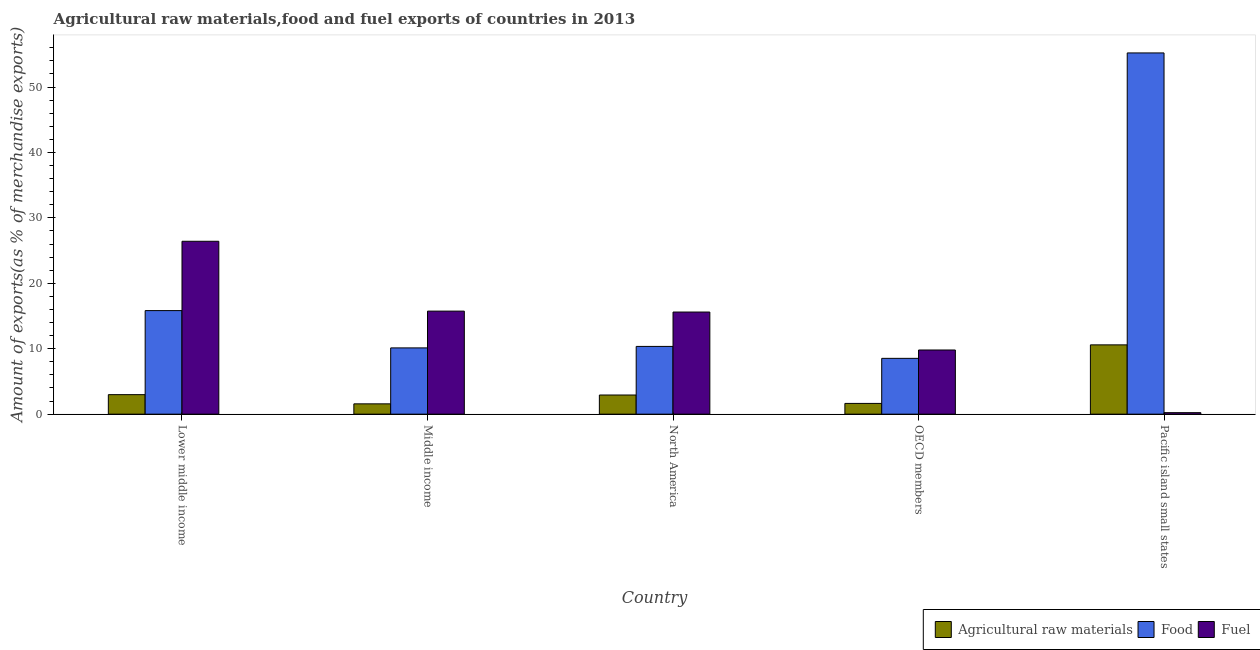How many different coloured bars are there?
Offer a terse response. 3. How many groups of bars are there?
Offer a terse response. 5. How many bars are there on the 1st tick from the left?
Offer a terse response. 3. What is the label of the 5th group of bars from the left?
Your answer should be very brief. Pacific island small states. In how many cases, is the number of bars for a given country not equal to the number of legend labels?
Provide a succinct answer. 0. What is the percentage of fuel exports in Middle income?
Provide a short and direct response. 15.75. Across all countries, what is the maximum percentage of raw materials exports?
Your answer should be very brief. 10.59. Across all countries, what is the minimum percentage of food exports?
Your answer should be compact. 8.53. In which country was the percentage of raw materials exports maximum?
Your answer should be very brief. Pacific island small states. In which country was the percentage of fuel exports minimum?
Your answer should be compact. Pacific island small states. What is the total percentage of food exports in the graph?
Provide a short and direct response. 100.06. What is the difference between the percentage of fuel exports in Lower middle income and that in North America?
Your response must be concise. 10.82. What is the difference between the percentage of fuel exports in Pacific island small states and the percentage of raw materials exports in OECD members?
Your answer should be compact. -1.41. What is the average percentage of food exports per country?
Keep it short and to the point. 20.01. What is the difference between the percentage of food exports and percentage of raw materials exports in Lower middle income?
Provide a short and direct response. 12.85. In how many countries, is the percentage of raw materials exports greater than 26 %?
Your response must be concise. 0. What is the ratio of the percentage of raw materials exports in Lower middle income to that in OECD members?
Give a very brief answer. 1.82. Is the percentage of fuel exports in Lower middle income less than that in Pacific island small states?
Keep it short and to the point. No. Is the difference between the percentage of fuel exports in North America and OECD members greater than the difference between the percentage of food exports in North America and OECD members?
Offer a terse response. Yes. What is the difference between the highest and the second highest percentage of raw materials exports?
Give a very brief answer. 7.61. What is the difference between the highest and the lowest percentage of fuel exports?
Provide a succinct answer. 26.19. In how many countries, is the percentage of fuel exports greater than the average percentage of fuel exports taken over all countries?
Your response must be concise. 3. Is the sum of the percentage of fuel exports in Middle income and Pacific island small states greater than the maximum percentage of food exports across all countries?
Give a very brief answer. No. What does the 2nd bar from the left in Middle income represents?
Your answer should be compact. Food. What does the 3rd bar from the right in Pacific island small states represents?
Your response must be concise. Agricultural raw materials. Is it the case that in every country, the sum of the percentage of raw materials exports and percentage of food exports is greater than the percentage of fuel exports?
Keep it short and to the point. No. Are all the bars in the graph horizontal?
Your answer should be compact. No. What is the difference between two consecutive major ticks on the Y-axis?
Ensure brevity in your answer.  10. Does the graph contain any zero values?
Your answer should be very brief. No. What is the title of the graph?
Keep it short and to the point. Agricultural raw materials,food and fuel exports of countries in 2013. What is the label or title of the Y-axis?
Ensure brevity in your answer.  Amount of exports(as % of merchandise exports). What is the Amount of exports(as % of merchandise exports) of Agricultural raw materials in Lower middle income?
Provide a succinct answer. 2.98. What is the Amount of exports(as % of merchandise exports) of Food in Lower middle income?
Make the answer very short. 15.83. What is the Amount of exports(as % of merchandise exports) of Fuel in Lower middle income?
Offer a very short reply. 26.42. What is the Amount of exports(as % of merchandise exports) of Agricultural raw materials in Middle income?
Ensure brevity in your answer.  1.58. What is the Amount of exports(as % of merchandise exports) in Food in Middle income?
Provide a short and direct response. 10.13. What is the Amount of exports(as % of merchandise exports) in Fuel in Middle income?
Keep it short and to the point. 15.75. What is the Amount of exports(as % of merchandise exports) of Agricultural raw materials in North America?
Offer a very short reply. 2.93. What is the Amount of exports(as % of merchandise exports) of Food in North America?
Offer a terse response. 10.35. What is the Amount of exports(as % of merchandise exports) in Fuel in North America?
Your response must be concise. 15.61. What is the Amount of exports(as % of merchandise exports) of Agricultural raw materials in OECD members?
Keep it short and to the point. 1.64. What is the Amount of exports(as % of merchandise exports) in Food in OECD members?
Provide a short and direct response. 8.53. What is the Amount of exports(as % of merchandise exports) in Fuel in OECD members?
Provide a short and direct response. 9.81. What is the Amount of exports(as % of merchandise exports) in Agricultural raw materials in Pacific island small states?
Your answer should be compact. 10.59. What is the Amount of exports(as % of merchandise exports) in Food in Pacific island small states?
Keep it short and to the point. 55.21. What is the Amount of exports(as % of merchandise exports) of Fuel in Pacific island small states?
Keep it short and to the point. 0.23. Across all countries, what is the maximum Amount of exports(as % of merchandise exports) in Agricultural raw materials?
Provide a short and direct response. 10.59. Across all countries, what is the maximum Amount of exports(as % of merchandise exports) in Food?
Your answer should be compact. 55.21. Across all countries, what is the maximum Amount of exports(as % of merchandise exports) of Fuel?
Your answer should be very brief. 26.42. Across all countries, what is the minimum Amount of exports(as % of merchandise exports) in Agricultural raw materials?
Provide a short and direct response. 1.58. Across all countries, what is the minimum Amount of exports(as % of merchandise exports) in Food?
Keep it short and to the point. 8.53. Across all countries, what is the minimum Amount of exports(as % of merchandise exports) in Fuel?
Provide a succinct answer. 0.23. What is the total Amount of exports(as % of merchandise exports) in Agricultural raw materials in the graph?
Your answer should be compact. 19.72. What is the total Amount of exports(as % of merchandise exports) in Food in the graph?
Make the answer very short. 100.06. What is the total Amount of exports(as % of merchandise exports) in Fuel in the graph?
Make the answer very short. 67.82. What is the difference between the Amount of exports(as % of merchandise exports) of Agricultural raw materials in Lower middle income and that in Middle income?
Ensure brevity in your answer.  1.41. What is the difference between the Amount of exports(as % of merchandise exports) of Food in Lower middle income and that in Middle income?
Your response must be concise. 5.7. What is the difference between the Amount of exports(as % of merchandise exports) in Fuel in Lower middle income and that in Middle income?
Make the answer very short. 10.67. What is the difference between the Amount of exports(as % of merchandise exports) of Agricultural raw materials in Lower middle income and that in North America?
Your answer should be compact. 0.05. What is the difference between the Amount of exports(as % of merchandise exports) of Food in Lower middle income and that in North America?
Provide a succinct answer. 5.48. What is the difference between the Amount of exports(as % of merchandise exports) in Fuel in Lower middle income and that in North America?
Your answer should be very brief. 10.82. What is the difference between the Amount of exports(as % of merchandise exports) of Agricultural raw materials in Lower middle income and that in OECD members?
Your response must be concise. 1.34. What is the difference between the Amount of exports(as % of merchandise exports) of Food in Lower middle income and that in OECD members?
Provide a succinct answer. 7.3. What is the difference between the Amount of exports(as % of merchandise exports) of Fuel in Lower middle income and that in OECD members?
Offer a very short reply. 16.62. What is the difference between the Amount of exports(as % of merchandise exports) in Agricultural raw materials in Lower middle income and that in Pacific island small states?
Offer a very short reply. -7.61. What is the difference between the Amount of exports(as % of merchandise exports) of Food in Lower middle income and that in Pacific island small states?
Make the answer very short. -39.38. What is the difference between the Amount of exports(as % of merchandise exports) in Fuel in Lower middle income and that in Pacific island small states?
Make the answer very short. 26.19. What is the difference between the Amount of exports(as % of merchandise exports) of Agricultural raw materials in Middle income and that in North America?
Your answer should be very brief. -1.35. What is the difference between the Amount of exports(as % of merchandise exports) in Food in Middle income and that in North America?
Offer a very short reply. -0.23. What is the difference between the Amount of exports(as % of merchandise exports) in Fuel in Middle income and that in North America?
Provide a succinct answer. 0.14. What is the difference between the Amount of exports(as % of merchandise exports) in Agricultural raw materials in Middle income and that in OECD members?
Provide a succinct answer. -0.07. What is the difference between the Amount of exports(as % of merchandise exports) of Food in Middle income and that in OECD members?
Make the answer very short. 1.6. What is the difference between the Amount of exports(as % of merchandise exports) in Fuel in Middle income and that in OECD members?
Provide a short and direct response. 5.94. What is the difference between the Amount of exports(as % of merchandise exports) of Agricultural raw materials in Middle income and that in Pacific island small states?
Your answer should be compact. -9.01. What is the difference between the Amount of exports(as % of merchandise exports) of Food in Middle income and that in Pacific island small states?
Your response must be concise. -45.08. What is the difference between the Amount of exports(as % of merchandise exports) in Fuel in Middle income and that in Pacific island small states?
Ensure brevity in your answer.  15.52. What is the difference between the Amount of exports(as % of merchandise exports) of Agricultural raw materials in North America and that in OECD members?
Provide a short and direct response. 1.29. What is the difference between the Amount of exports(as % of merchandise exports) of Food in North America and that in OECD members?
Offer a terse response. 1.82. What is the difference between the Amount of exports(as % of merchandise exports) of Fuel in North America and that in OECD members?
Your response must be concise. 5.8. What is the difference between the Amount of exports(as % of merchandise exports) of Agricultural raw materials in North America and that in Pacific island small states?
Provide a succinct answer. -7.66. What is the difference between the Amount of exports(as % of merchandise exports) of Food in North America and that in Pacific island small states?
Provide a succinct answer. -44.86. What is the difference between the Amount of exports(as % of merchandise exports) in Fuel in North America and that in Pacific island small states?
Offer a very short reply. 15.38. What is the difference between the Amount of exports(as % of merchandise exports) in Agricultural raw materials in OECD members and that in Pacific island small states?
Keep it short and to the point. -8.95. What is the difference between the Amount of exports(as % of merchandise exports) in Food in OECD members and that in Pacific island small states?
Ensure brevity in your answer.  -46.68. What is the difference between the Amount of exports(as % of merchandise exports) of Fuel in OECD members and that in Pacific island small states?
Give a very brief answer. 9.58. What is the difference between the Amount of exports(as % of merchandise exports) of Agricultural raw materials in Lower middle income and the Amount of exports(as % of merchandise exports) of Food in Middle income?
Provide a succinct answer. -7.14. What is the difference between the Amount of exports(as % of merchandise exports) of Agricultural raw materials in Lower middle income and the Amount of exports(as % of merchandise exports) of Fuel in Middle income?
Offer a very short reply. -12.77. What is the difference between the Amount of exports(as % of merchandise exports) of Food in Lower middle income and the Amount of exports(as % of merchandise exports) of Fuel in Middle income?
Keep it short and to the point. 0.08. What is the difference between the Amount of exports(as % of merchandise exports) of Agricultural raw materials in Lower middle income and the Amount of exports(as % of merchandise exports) of Food in North America?
Give a very brief answer. -7.37. What is the difference between the Amount of exports(as % of merchandise exports) in Agricultural raw materials in Lower middle income and the Amount of exports(as % of merchandise exports) in Fuel in North America?
Your response must be concise. -12.63. What is the difference between the Amount of exports(as % of merchandise exports) in Food in Lower middle income and the Amount of exports(as % of merchandise exports) in Fuel in North America?
Provide a succinct answer. 0.22. What is the difference between the Amount of exports(as % of merchandise exports) of Agricultural raw materials in Lower middle income and the Amount of exports(as % of merchandise exports) of Food in OECD members?
Your answer should be very brief. -5.55. What is the difference between the Amount of exports(as % of merchandise exports) of Agricultural raw materials in Lower middle income and the Amount of exports(as % of merchandise exports) of Fuel in OECD members?
Provide a succinct answer. -6.82. What is the difference between the Amount of exports(as % of merchandise exports) of Food in Lower middle income and the Amount of exports(as % of merchandise exports) of Fuel in OECD members?
Make the answer very short. 6.02. What is the difference between the Amount of exports(as % of merchandise exports) in Agricultural raw materials in Lower middle income and the Amount of exports(as % of merchandise exports) in Food in Pacific island small states?
Offer a very short reply. -52.23. What is the difference between the Amount of exports(as % of merchandise exports) of Agricultural raw materials in Lower middle income and the Amount of exports(as % of merchandise exports) of Fuel in Pacific island small states?
Your answer should be compact. 2.75. What is the difference between the Amount of exports(as % of merchandise exports) in Food in Lower middle income and the Amount of exports(as % of merchandise exports) in Fuel in Pacific island small states?
Provide a short and direct response. 15.6. What is the difference between the Amount of exports(as % of merchandise exports) of Agricultural raw materials in Middle income and the Amount of exports(as % of merchandise exports) of Food in North America?
Make the answer very short. -8.78. What is the difference between the Amount of exports(as % of merchandise exports) in Agricultural raw materials in Middle income and the Amount of exports(as % of merchandise exports) in Fuel in North America?
Ensure brevity in your answer.  -14.03. What is the difference between the Amount of exports(as % of merchandise exports) in Food in Middle income and the Amount of exports(as % of merchandise exports) in Fuel in North America?
Provide a short and direct response. -5.48. What is the difference between the Amount of exports(as % of merchandise exports) of Agricultural raw materials in Middle income and the Amount of exports(as % of merchandise exports) of Food in OECD members?
Keep it short and to the point. -6.95. What is the difference between the Amount of exports(as % of merchandise exports) in Agricultural raw materials in Middle income and the Amount of exports(as % of merchandise exports) in Fuel in OECD members?
Offer a terse response. -8.23. What is the difference between the Amount of exports(as % of merchandise exports) in Food in Middle income and the Amount of exports(as % of merchandise exports) in Fuel in OECD members?
Your answer should be compact. 0.32. What is the difference between the Amount of exports(as % of merchandise exports) in Agricultural raw materials in Middle income and the Amount of exports(as % of merchandise exports) in Food in Pacific island small states?
Your response must be concise. -53.64. What is the difference between the Amount of exports(as % of merchandise exports) of Agricultural raw materials in Middle income and the Amount of exports(as % of merchandise exports) of Fuel in Pacific island small states?
Your answer should be very brief. 1.35. What is the difference between the Amount of exports(as % of merchandise exports) of Food in Middle income and the Amount of exports(as % of merchandise exports) of Fuel in Pacific island small states?
Offer a terse response. 9.9. What is the difference between the Amount of exports(as % of merchandise exports) in Agricultural raw materials in North America and the Amount of exports(as % of merchandise exports) in Food in OECD members?
Provide a short and direct response. -5.6. What is the difference between the Amount of exports(as % of merchandise exports) of Agricultural raw materials in North America and the Amount of exports(as % of merchandise exports) of Fuel in OECD members?
Offer a terse response. -6.88. What is the difference between the Amount of exports(as % of merchandise exports) in Food in North America and the Amount of exports(as % of merchandise exports) in Fuel in OECD members?
Give a very brief answer. 0.55. What is the difference between the Amount of exports(as % of merchandise exports) of Agricultural raw materials in North America and the Amount of exports(as % of merchandise exports) of Food in Pacific island small states?
Your answer should be compact. -52.28. What is the difference between the Amount of exports(as % of merchandise exports) in Agricultural raw materials in North America and the Amount of exports(as % of merchandise exports) in Fuel in Pacific island small states?
Provide a short and direct response. 2.7. What is the difference between the Amount of exports(as % of merchandise exports) in Food in North America and the Amount of exports(as % of merchandise exports) in Fuel in Pacific island small states?
Keep it short and to the point. 10.12. What is the difference between the Amount of exports(as % of merchandise exports) of Agricultural raw materials in OECD members and the Amount of exports(as % of merchandise exports) of Food in Pacific island small states?
Make the answer very short. -53.57. What is the difference between the Amount of exports(as % of merchandise exports) in Agricultural raw materials in OECD members and the Amount of exports(as % of merchandise exports) in Fuel in Pacific island small states?
Offer a terse response. 1.41. What is the difference between the Amount of exports(as % of merchandise exports) of Food in OECD members and the Amount of exports(as % of merchandise exports) of Fuel in Pacific island small states?
Keep it short and to the point. 8.3. What is the average Amount of exports(as % of merchandise exports) in Agricultural raw materials per country?
Make the answer very short. 3.94. What is the average Amount of exports(as % of merchandise exports) in Food per country?
Your response must be concise. 20.01. What is the average Amount of exports(as % of merchandise exports) of Fuel per country?
Offer a terse response. 13.56. What is the difference between the Amount of exports(as % of merchandise exports) of Agricultural raw materials and Amount of exports(as % of merchandise exports) of Food in Lower middle income?
Make the answer very short. -12.85. What is the difference between the Amount of exports(as % of merchandise exports) in Agricultural raw materials and Amount of exports(as % of merchandise exports) in Fuel in Lower middle income?
Your answer should be very brief. -23.44. What is the difference between the Amount of exports(as % of merchandise exports) in Food and Amount of exports(as % of merchandise exports) in Fuel in Lower middle income?
Provide a succinct answer. -10.59. What is the difference between the Amount of exports(as % of merchandise exports) of Agricultural raw materials and Amount of exports(as % of merchandise exports) of Food in Middle income?
Provide a short and direct response. -8.55. What is the difference between the Amount of exports(as % of merchandise exports) of Agricultural raw materials and Amount of exports(as % of merchandise exports) of Fuel in Middle income?
Offer a terse response. -14.17. What is the difference between the Amount of exports(as % of merchandise exports) of Food and Amount of exports(as % of merchandise exports) of Fuel in Middle income?
Keep it short and to the point. -5.62. What is the difference between the Amount of exports(as % of merchandise exports) of Agricultural raw materials and Amount of exports(as % of merchandise exports) of Food in North America?
Provide a short and direct response. -7.43. What is the difference between the Amount of exports(as % of merchandise exports) of Agricultural raw materials and Amount of exports(as % of merchandise exports) of Fuel in North America?
Offer a terse response. -12.68. What is the difference between the Amount of exports(as % of merchandise exports) in Food and Amount of exports(as % of merchandise exports) in Fuel in North America?
Ensure brevity in your answer.  -5.25. What is the difference between the Amount of exports(as % of merchandise exports) in Agricultural raw materials and Amount of exports(as % of merchandise exports) in Food in OECD members?
Offer a terse response. -6.89. What is the difference between the Amount of exports(as % of merchandise exports) of Agricultural raw materials and Amount of exports(as % of merchandise exports) of Fuel in OECD members?
Your answer should be very brief. -8.16. What is the difference between the Amount of exports(as % of merchandise exports) in Food and Amount of exports(as % of merchandise exports) in Fuel in OECD members?
Offer a very short reply. -1.28. What is the difference between the Amount of exports(as % of merchandise exports) of Agricultural raw materials and Amount of exports(as % of merchandise exports) of Food in Pacific island small states?
Your answer should be very brief. -44.62. What is the difference between the Amount of exports(as % of merchandise exports) in Agricultural raw materials and Amount of exports(as % of merchandise exports) in Fuel in Pacific island small states?
Keep it short and to the point. 10.36. What is the difference between the Amount of exports(as % of merchandise exports) in Food and Amount of exports(as % of merchandise exports) in Fuel in Pacific island small states?
Your answer should be very brief. 54.98. What is the ratio of the Amount of exports(as % of merchandise exports) in Agricultural raw materials in Lower middle income to that in Middle income?
Offer a very short reply. 1.89. What is the ratio of the Amount of exports(as % of merchandise exports) of Food in Lower middle income to that in Middle income?
Your answer should be compact. 1.56. What is the ratio of the Amount of exports(as % of merchandise exports) in Fuel in Lower middle income to that in Middle income?
Provide a succinct answer. 1.68. What is the ratio of the Amount of exports(as % of merchandise exports) of Agricultural raw materials in Lower middle income to that in North America?
Provide a succinct answer. 1.02. What is the ratio of the Amount of exports(as % of merchandise exports) of Food in Lower middle income to that in North America?
Make the answer very short. 1.53. What is the ratio of the Amount of exports(as % of merchandise exports) of Fuel in Lower middle income to that in North America?
Provide a succinct answer. 1.69. What is the ratio of the Amount of exports(as % of merchandise exports) of Agricultural raw materials in Lower middle income to that in OECD members?
Give a very brief answer. 1.82. What is the ratio of the Amount of exports(as % of merchandise exports) of Food in Lower middle income to that in OECD members?
Ensure brevity in your answer.  1.86. What is the ratio of the Amount of exports(as % of merchandise exports) of Fuel in Lower middle income to that in OECD members?
Your answer should be compact. 2.69. What is the ratio of the Amount of exports(as % of merchandise exports) in Agricultural raw materials in Lower middle income to that in Pacific island small states?
Offer a terse response. 0.28. What is the ratio of the Amount of exports(as % of merchandise exports) in Food in Lower middle income to that in Pacific island small states?
Ensure brevity in your answer.  0.29. What is the ratio of the Amount of exports(as % of merchandise exports) in Fuel in Lower middle income to that in Pacific island small states?
Make the answer very short. 114.87. What is the ratio of the Amount of exports(as % of merchandise exports) of Agricultural raw materials in Middle income to that in North America?
Offer a terse response. 0.54. What is the ratio of the Amount of exports(as % of merchandise exports) in Food in Middle income to that in North America?
Your answer should be very brief. 0.98. What is the ratio of the Amount of exports(as % of merchandise exports) in Fuel in Middle income to that in North America?
Your response must be concise. 1.01. What is the ratio of the Amount of exports(as % of merchandise exports) of Agricultural raw materials in Middle income to that in OECD members?
Give a very brief answer. 0.96. What is the ratio of the Amount of exports(as % of merchandise exports) of Food in Middle income to that in OECD members?
Your answer should be compact. 1.19. What is the ratio of the Amount of exports(as % of merchandise exports) of Fuel in Middle income to that in OECD members?
Offer a very short reply. 1.61. What is the ratio of the Amount of exports(as % of merchandise exports) in Agricultural raw materials in Middle income to that in Pacific island small states?
Your answer should be compact. 0.15. What is the ratio of the Amount of exports(as % of merchandise exports) in Food in Middle income to that in Pacific island small states?
Provide a succinct answer. 0.18. What is the ratio of the Amount of exports(as % of merchandise exports) in Fuel in Middle income to that in Pacific island small states?
Give a very brief answer. 68.47. What is the ratio of the Amount of exports(as % of merchandise exports) of Agricultural raw materials in North America to that in OECD members?
Your answer should be compact. 1.78. What is the ratio of the Amount of exports(as % of merchandise exports) of Food in North America to that in OECD members?
Keep it short and to the point. 1.21. What is the ratio of the Amount of exports(as % of merchandise exports) in Fuel in North America to that in OECD members?
Your response must be concise. 1.59. What is the ratio of the Amount of exports(as % of merchandise exports) of Agricultural raw materials in North America to that in Pacific island small states?
Your answer should be compact. 0.28. What is the ratio of the Amount of exports(as % of merchandise exports) in Food in North America to that in Pacific island small states?
Provide a succinct answer. 0.19. What is the ratio of the Amount of exports(as % of merchandise exports) in Fuel in North America to that in Pacific island small states?
Your answer should be compact. 67.85. What is the ratio of the Amount of exports(as % of merchandise exports) in Agricultural raw materials in OECD members to that in Pacific island small states?
Offer a terse response. 0.16. What is the ratio of the Amount of exports(as % of merchandise exports) in Food in OECD members to that in Pacific island small states?
Your answer should be compact. 0.15. What is the ratio of the Amount of exports(as % of merchandise exports) in Fuel in OECD members to that in Pacific island small states?
Your answer should be compact. 42.64. What is the difference between the highest and the second highest Amount of exports(as % of merchandise exports) of Agricultural raw materials?
Offer a terse response. 7.61. What is the difference between the highest and the second highest Amount of exports(as % of merchandise exports) in Food?
Your response must be concise. 39.38. What is the difference between the highest and the second highest Amount of exports(as % of merchandise exports) in Fuel?
Ensure brevity in your answer.  10.67. What is the difference between the highest and the lowest Amount of exports(as % of merchandise exports) of Agricultural raw materials?
Offer a terse response. 9.01. What is the difference between the highest and the lowest Amount of exports(as % of merchandise exports) of Food?
Your answer should be compact. 46.68. What is the difference between the highest and the lowest Amount of exports(as % of merchandise exports) of Fuel?
Keep it short and to the point. 26.19. 